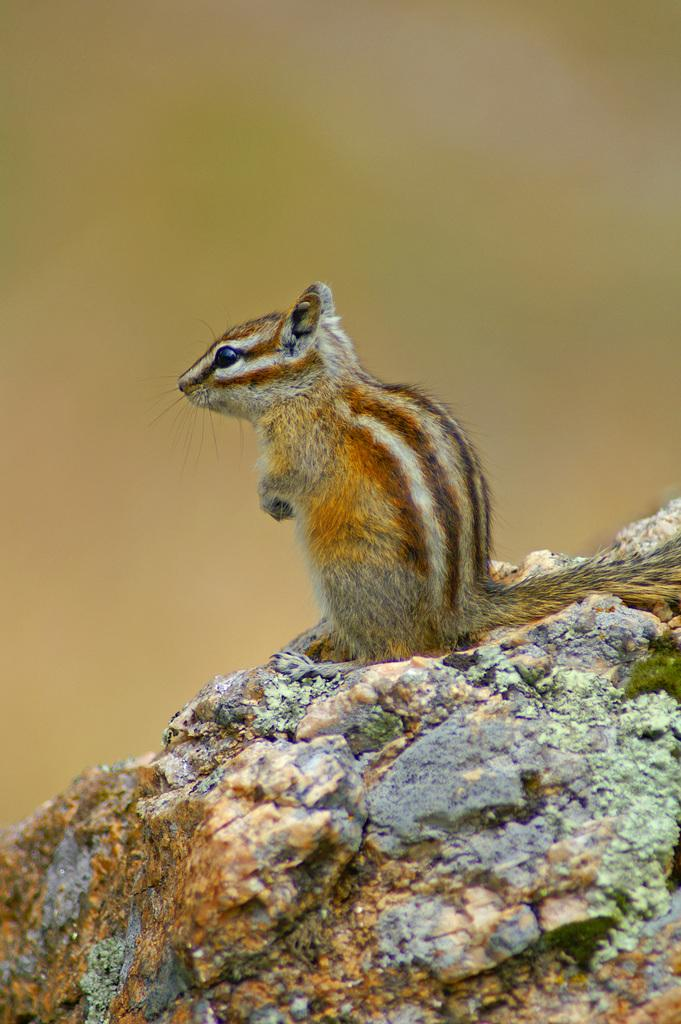What animal can be seen in the image? There is a squirrel in the image. Where is the squirrel located? The squirrel is sitting on a rock. Can you describe the background of the image? The background of the image is blurry. What type of popcorn is the squirrel eating in the image? There is no popcorn present in the image; the squirrel is sitting on a rock. What place is the squirrel reading a book in the image? There is no place or book mentioned in the image; the squirrel is sitting on a rock. 